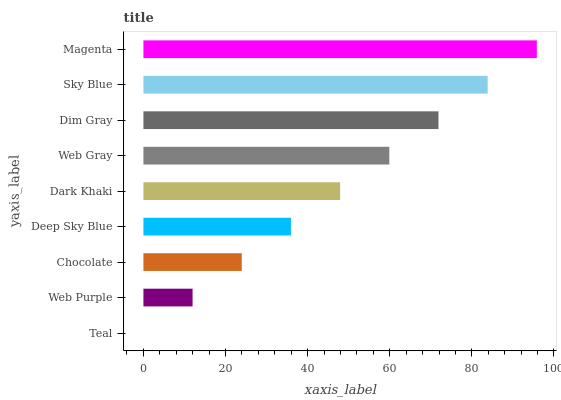Is Teal the minimum?
Answer yes or no. Yes. Is Magenta the maximum?
Answer yes or no. Yes. Is Web Purple the minimum?
Answer yes or no. No. Is Web Purple the maximum?
Answer yes or no. No. Is Web Purple greater than Teal?
Answer yes or no. Yes. Is Teal less than Web Purple?
Answer yes or no. Yes. Is Teal greater than Web Purple?
Answer yes or no. No. Is Web Purple less than Teal?
Answer yes or no. No. Is Dark Khaki the high median?
Answer yes or no. Yes. Is Dark Khaki the low median?
Answer yes or no. Yes. Is Magenta the high median?
Answer yes or no. No. Is Chocolate the low median?
Answer yes or no. No. 